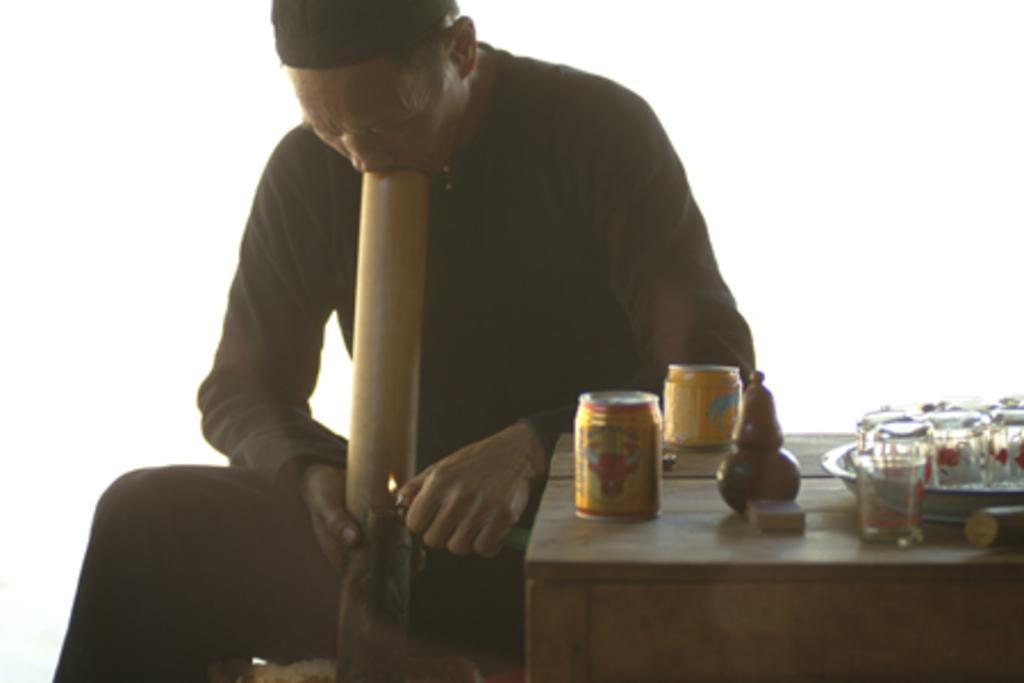How would you summarize this image in a sentence or two? In this image I see a man and there is a table over here and there are few things on it. 